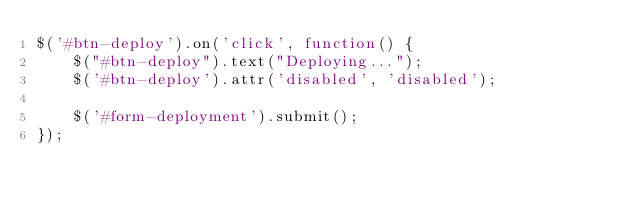<code> <loc_0><loc_0><loc_500><loc_500><_JavaScript_>$('#btn-deploy').on('click', function() {
    $("#btn-deploy").text("Deploying...");
    $('#btn-deploy').attr('disabled', 'disabled');

    $('#form-deployment').submit();
});
</code> 